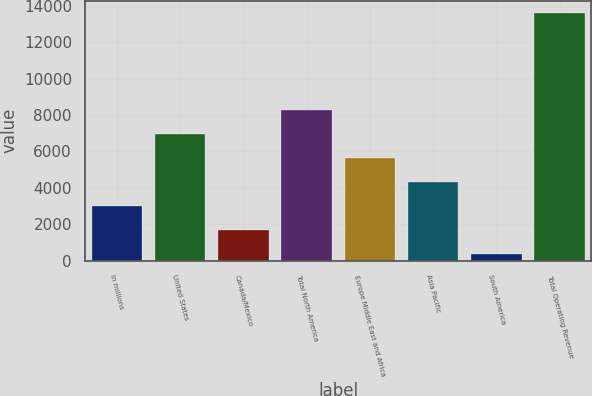Convert chart. <chart><loc_0><loc_0><loc_500><loc_500><bar_chart><fcel>In millions<fcel>United States<fcel>Canada/Mexico<fcel>Total North America<fcel>Europe Middle East and Africa<fcel>Asia Pacific<fcel>South America<fcel>Total Operating Revenue<nl><fcel>3001.4<fcel>6975.5<fcel>1676.7<fcel>8300.2<fcel>5650.8<fcel>4326.1<fcel>352<fcel>13599<nl></chart> 